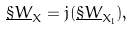<formula> <loc_0><loc_0><loc_500><loc_500>\underline { \S W } _ { X } = j ( \underline { \S W } _ { X _ { 1 } } ) ,</formula> 